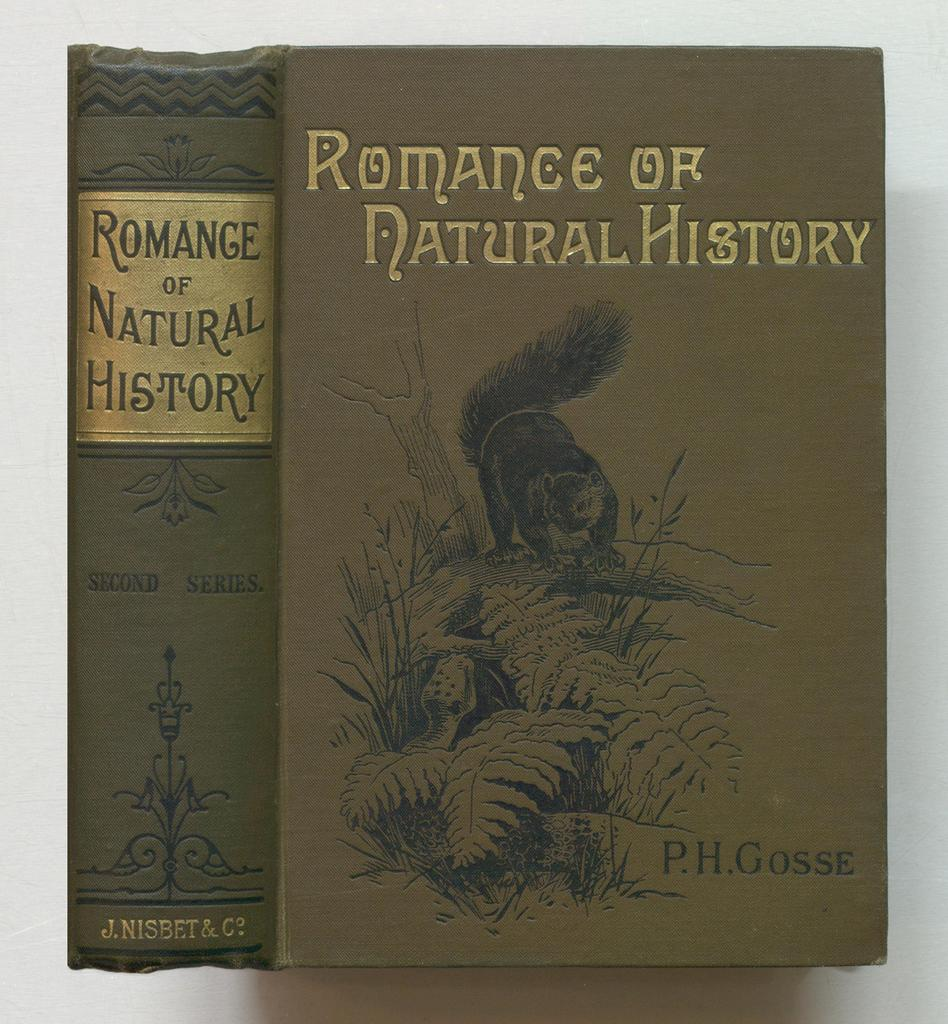<image>
Share a concise interpretation of the image provided. A green book with gold print titled Romance of Natural History. 